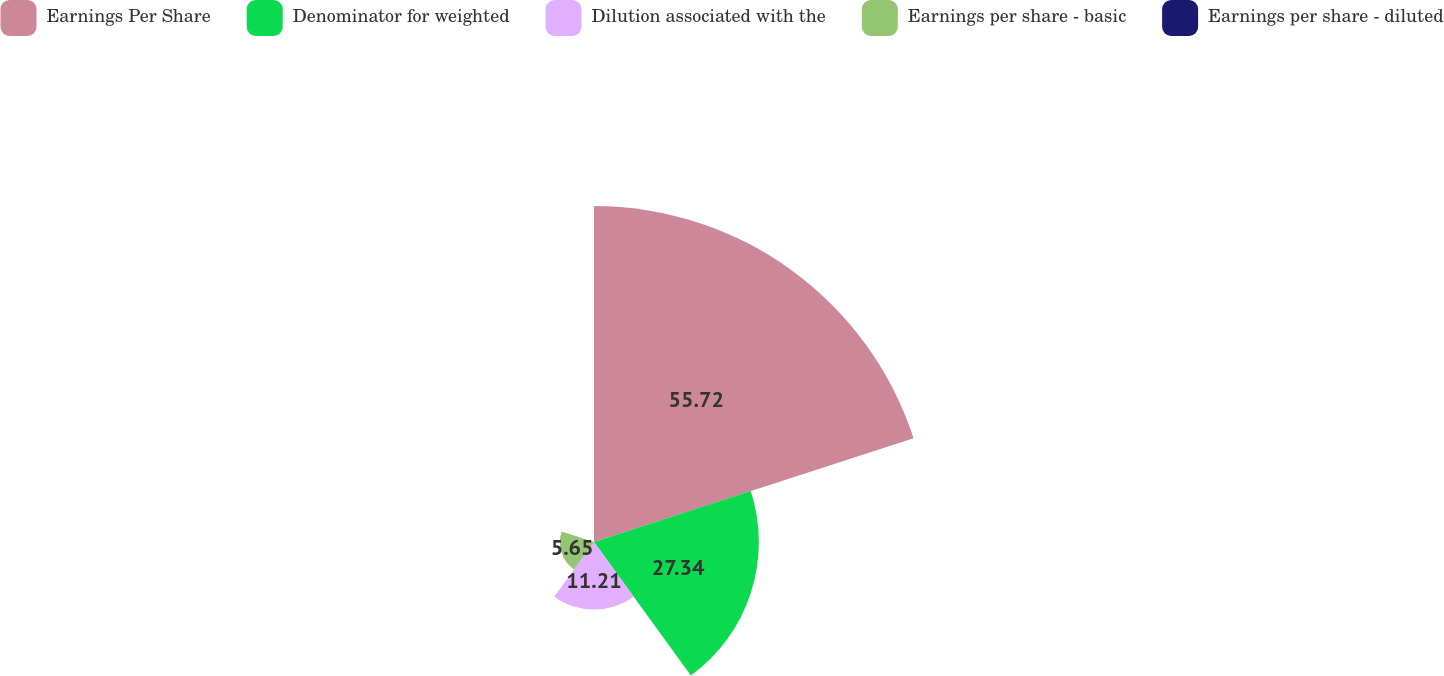Convert chart to OTSL. <chart><loc_0><loc_0><loc_500><loc_500><pie_chart><fcel>Earnings Per Share<fcel>Denominator for weighted<fcel>Dilution associated with the<fcel>Earnings per share - basic<fcel>Earnings per share - diluted<nl><fcel>55.72%<fcel>27.34%<fcel>11.21%<fcel>5.65%<fcel>0.08%<nl></chart> 